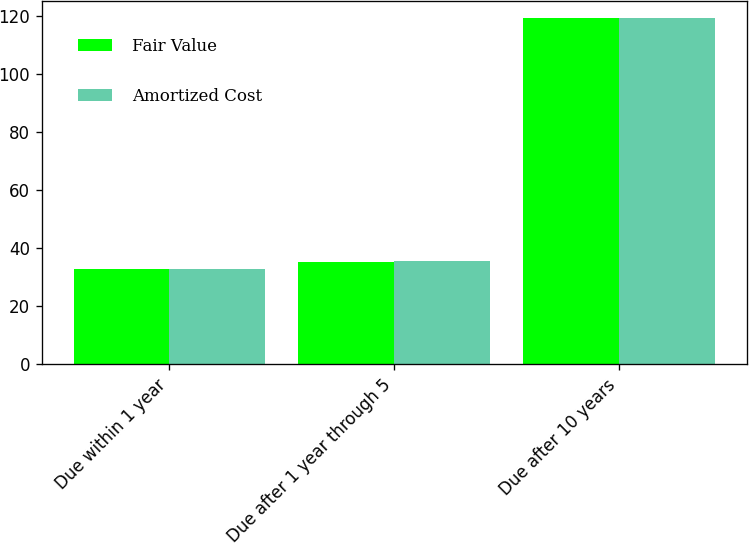Convert chart. <chart><loc_0><loc_0><loc_500><loc_500><stacked_bar_chart><ecel><fcel>Due within 1 year<fcel>Due after 1 year through 5<fcel>Due after 10 years<nl><fcel>Fair Value<fcel>32.8<fcel>35.1<fcel>119.4<nl><fcel>Amortized Cost<fcel>33<fcel>35.6<fcel>119.4<nl></chart> 